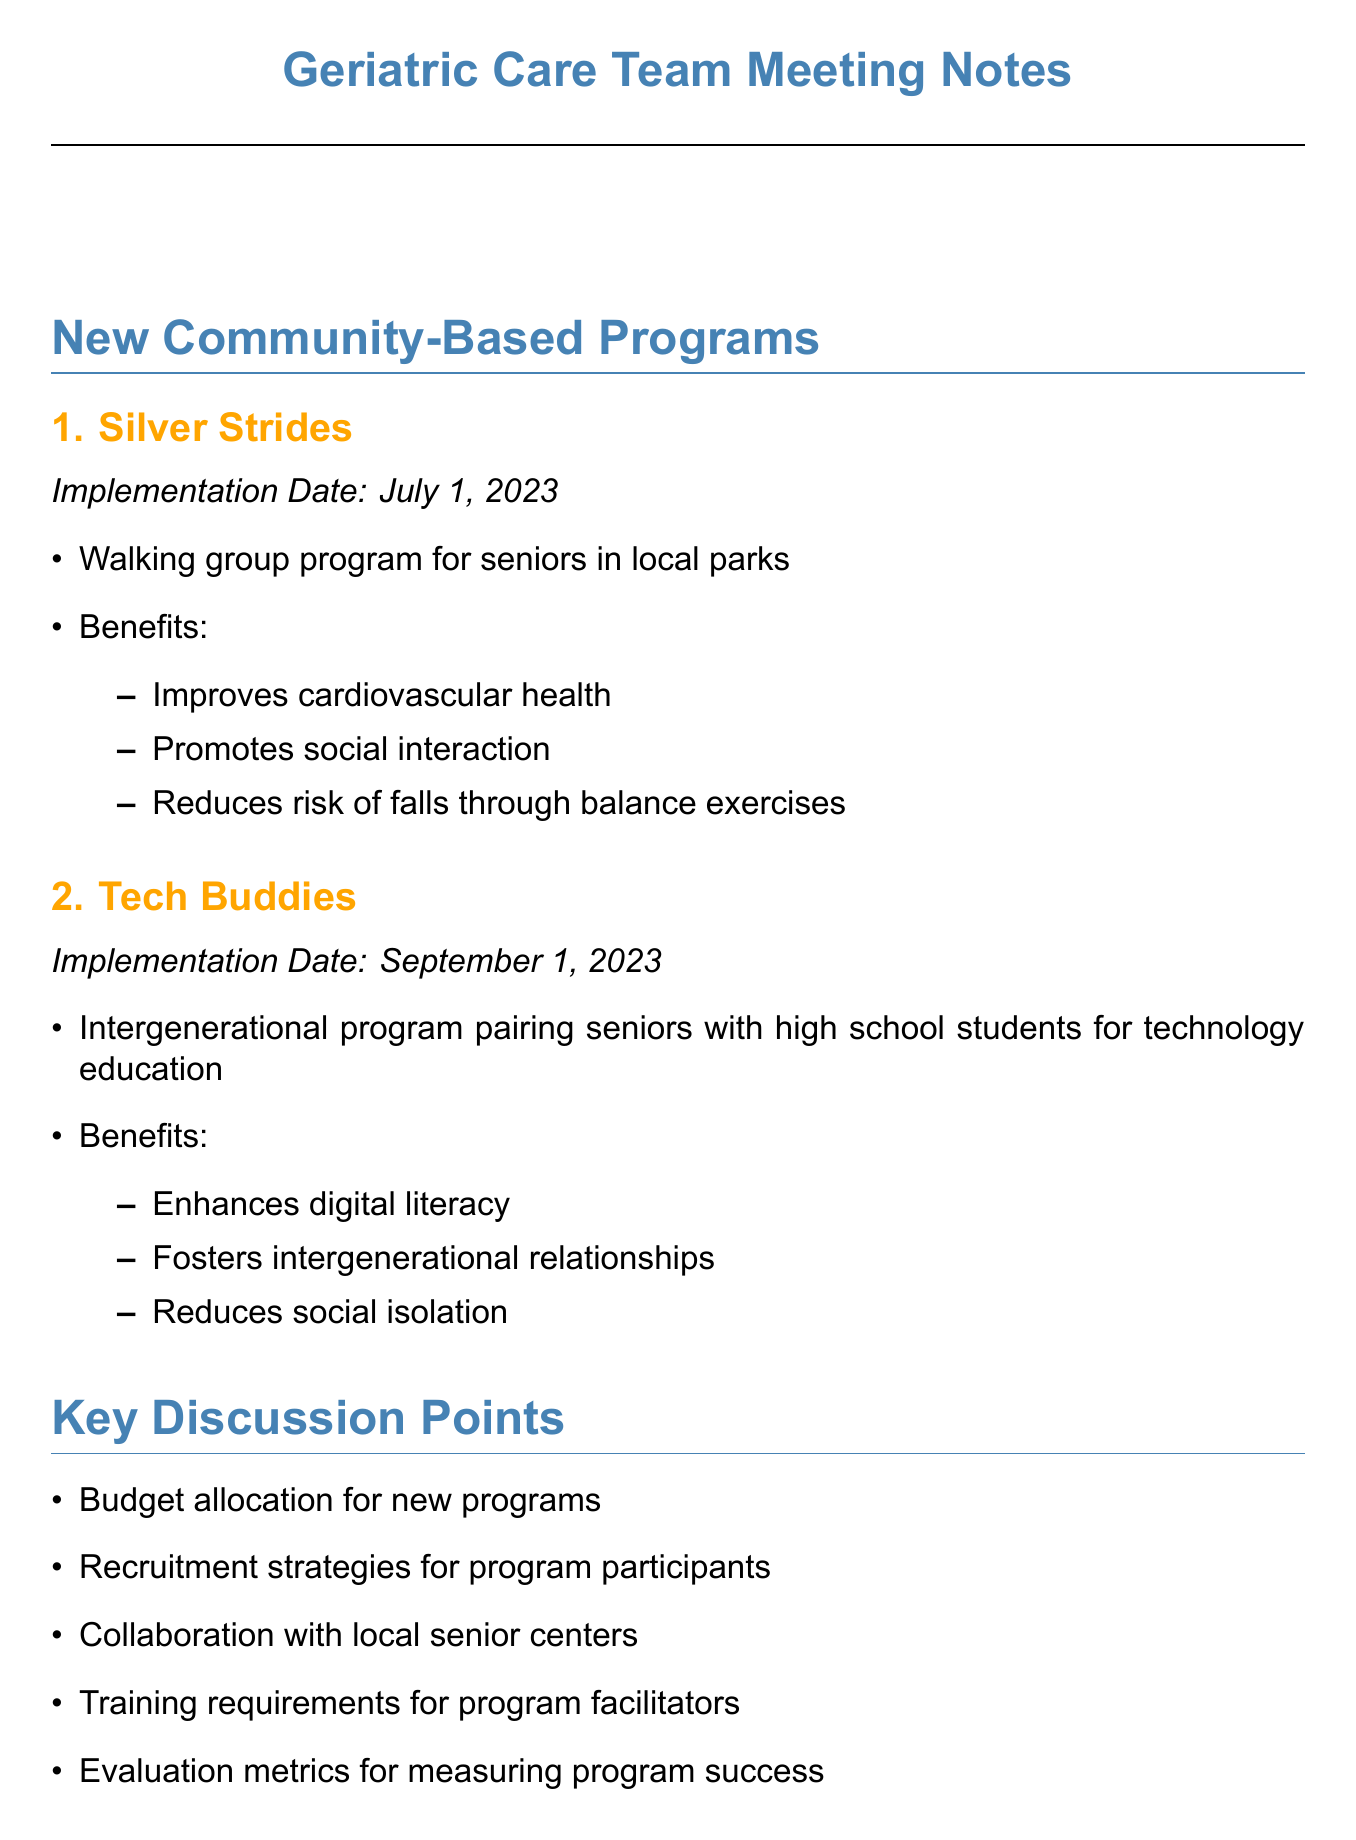What is the implementation date for Silver Strides? The implementation date for Silver Strides is provided in the document.
Answer: July 1, 2023 Who presented at the meeting as the Community Outreach Coordinator? The document lists the attendees and their roles, identifying the Community Outreach Coordinator.
Answer: Mark Thompson What are the benefits of the Tech Buddies program? The document outlines the benefits of the Tech Buddies program, detailing its positive impacts.
Answer: Enhances digital literacy, fosters intergenerational relationships, reduces social isolation What key discussion point relates to ensuring program success? The document includes key discussion points that address various aspects of the new programs, one of which is focused on evaluation.
Answer: Evaluation metrics for measuring program success Which social worker is responsible for developing outreach materials? The action items section specifies the responsibilities assigned to different attendees.
Answer: Sarah What challenge is identified regarding program attendance? The document lists challenges identified during the meeting, one specifically related to the attendance of seniors.
Answer: Ensuring consistent attendance in programs When is the follow-up meeting scheduled? The next steps section includes the date for the follow-up meeting.
Answer: June 1, 2023 What type of exercises will Lisa design for Silver Strides? The action items specify the responsibilities for designing specific components of the Silver Strides program.
Answer: Fall prevention exercises 